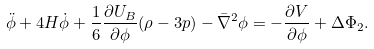<formula> <loc_0><loc_0><loc_500><loc_500>\ddot { \phi } + 4 H \dot { \phi } + \frac { 1 } { 6 } \frac { \partial U _ { B } } { \partial \phi } ( \rho - 3 p ) - \bar { \nabla } ^ { 2 } \phi = - \frac { \partial V } { \partial \phi } + \Delta \Phi _ { 2 } .</formula> 